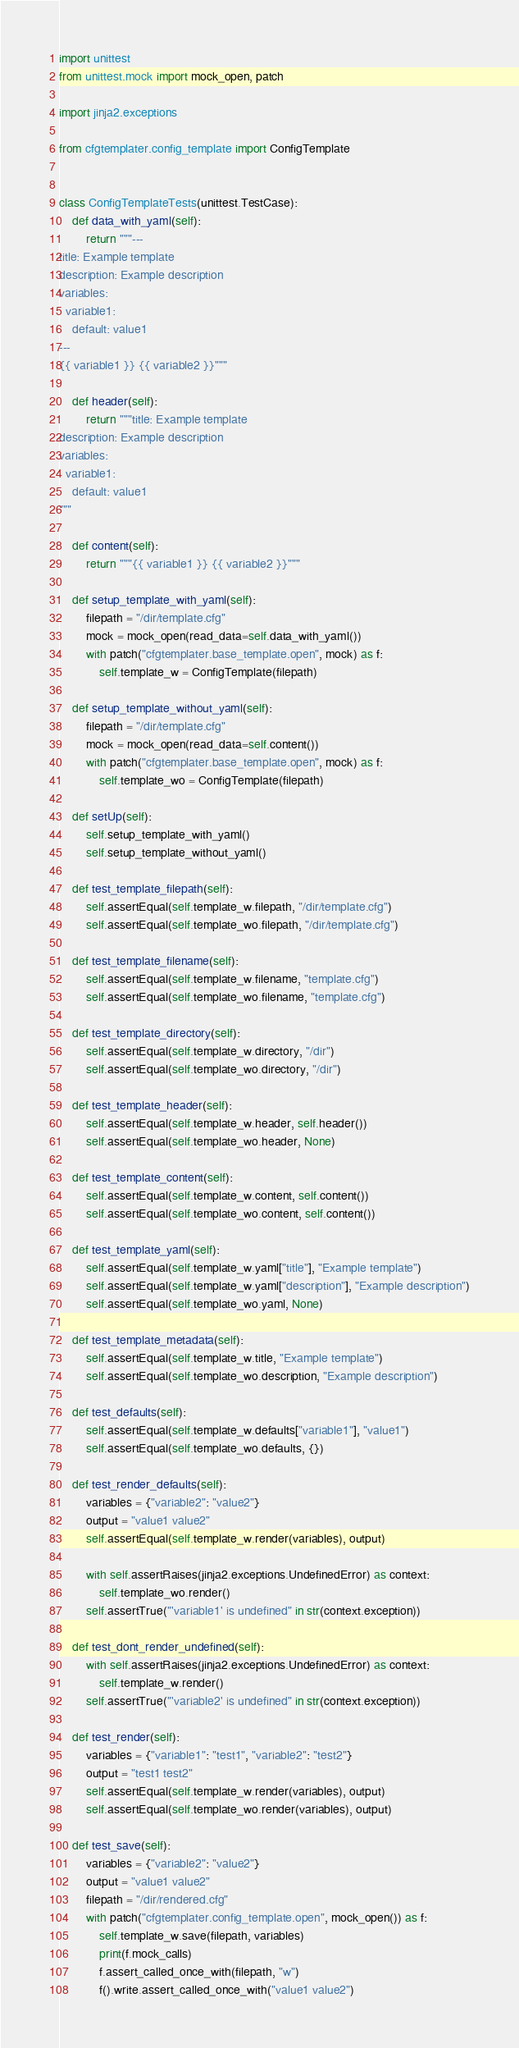<code> <loc_0><loc_0><loc_500><loc_500><_Python_>import unittest
from unittest.mock import mock_open, patch

import jinja2.exceptions

from cfgtemplater.config_template import ConfigTemplate


class ConfigTemplateTests(unittest.TestCase):
    def data_with_yaml(self):
        return """---
title: Example template
description: Example description
variables:
  variable1:
    default: value1
---
{{ variable1 }} {{ variable2 }}"""

    def header(self):
        return """title: Example template
description: Example description
variables:
  variable1:
    default: value1
"""

    def content(self):
        return """{{ variable1 }} {{ variable2 }}"""

    def setup_template_with_yaml(self):
        filepath = "/dir/template.cfg"
        mock = mock_open(read_data=self.data_with_yaml())
        with patch("cfgtemplater.base_template.open", mock) as f:
            self.template_w = ConfigTemplate(filepath)

    def setup_template_without_yaml(self):
        filepath = "/dir/template.cfg"
        mock = mock_open(read_data=self.content())
        with patch("cfgtemplater.base_template.open", mock) as f:
            self.template_wo = ConfigTemplate(filepath)

    def setUp(self):
        self.setup_template_with_yaml()
        self.setup_template_without_yaml()

    def test_template_filepath(self):
        self.assertEqual(self.template_w.filepath, "/dir/template.cfg")
        self.assertEqual(self.template_wo.filepath, "/dir/template.cfg")

    def test_template_filename(self):
        self.assertEqual(self.template_w.filename, "template.cfg")
        self.assertEqual(self.template_wo.filename, "template.cfg")

    def test_template_directory(self):
        self.assertEqual(self.template_w.directory, "/dir")
        self.assertEqual(self.template_wo.directory, "/dir")

    def test_template_header(self):
        self.assertEqual(self.template_w.header, self.header())
        self.assertEqual(self.template_wo.header, None)

    def test_template_content(self):
        self.assertEqual(self.template_w.content, self.content())
        self.assertEqual(self.template_wo.content, self.content())

    def test_template_yaml(self):
        self.assertEqual(self.template_w.yaml["title"], "Example template")
        self.assertEqual(self.template_w.yaml["description"], "Example description")
        self.assertEqual(self.template_wo.yaml, None)

    def test_template_metadata(self):
        self.assertEqual(self.template_w.title, "Example template")
        self.assertEqual(self.template_wo.description, "Example description")

    def test_defaults(self):
        self.assertEqual(self.template_w.defaults["variable1"], "value1")
        self.assertEqual(self.template_wo.defaults, {})

    def test_render_defaults(self):
        variables = {"variable2": "value2"}
        output = "value1 value2"
        self.assertEqual(self.template_w.render(variables), output)

        with self.assertRaises(jinja2.exceptions.UndefinedError) as context:
            self.template_wo.render()
        self.assertTrue("'variable1' is undefined" in str(context.exception))

    def test_dont_render_undefined(self):
        with self.assertRaises(jinja2.exceptions.UndefinedError) as context:
            self.template_w.render()
        self.assertTrue("'variable2' is undefined" in str(context.exception))

    def test_render(self):
        variables = {"variable1": "test1", "variable2": "test2"}
        output = "test1 test2"
        self.assertEqual(self.template_w.render(variables), output)
        self.assertEqual(self.template_wo.render(variables), output)

    def test_save(self):
        variables = {"variable2": "value2"}
        output = "value1 value2"
        filepath = "/dir/rendered.cfg"
        with patch("cfgtemplater.config_template.open", mock_open()) as f:
            self.template_w.save(filepath, variables)
            print(f.mock_calls)
            f.assert_called_once_with(filepath, "w")
            f().write.assert_called_once_with("value1 value2")
</code> 